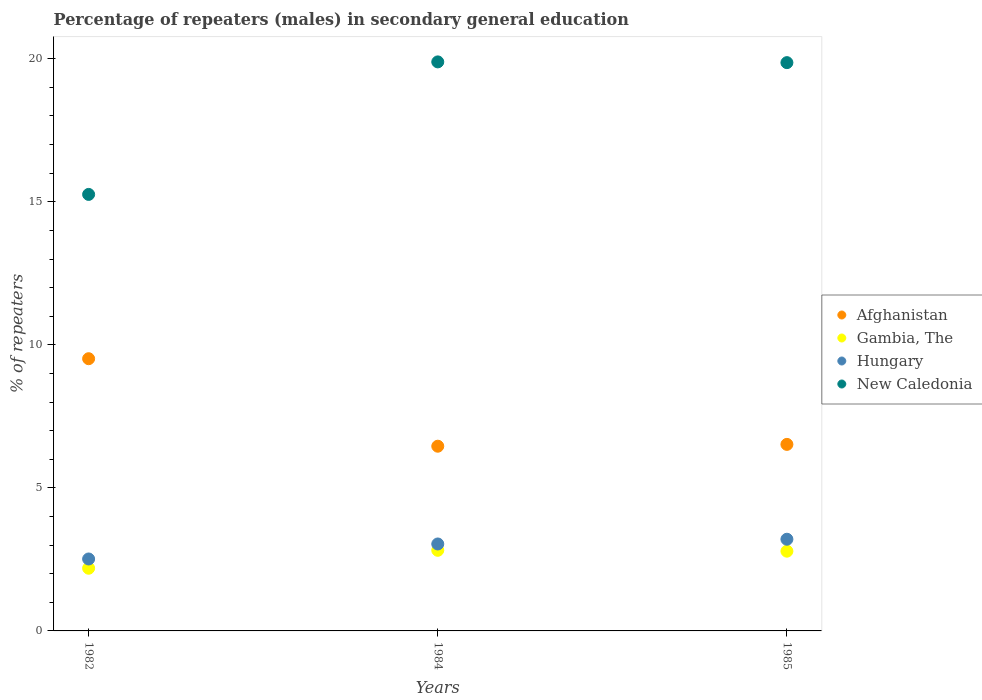Is the number of dotlines equal to the number of legend labels?
Ensure brevity in your answer.  Yes. What is the percentage of male repeaters in New Caledonia in 1985?
Give a very brief answer. 19.86. Across all years, what is the maximum percentage of male repeaters in Gambia, The?
Give a very brief answer. 2.82. Across all years, what is the minimum percentage of male repeaters in New Caledonia?
Offer a terse response. 15.26. In which year was the percentage of male repeaters in New Caledonia minimum?
Offer a terse response. 1982. What is the total percentage of male repeaters in Hungary in the graph?
Keep it short and to the point. 8.76. What is the difference between the percentage of male repeaters in Afghanistan in 1982 and that in 1984?
Keep it short and to the point. 3.06. What is the difference between the percentage of male repeaters in Afghanistan in 1985 and the percentage of male repeaters in New Caledonia in 1984?
Make the answer very short. -13.37. What is the average percentage of male repeaters in Gambia, The per year?
Your response must be concise. 2.6. In the year 1982, what is the difference between the percentage of male repeaters in Gambia, The and percentage of male repeaters in Hungary?
Offer a terse response. -0.32. In how many years, is the percentage of male repeaters in Afghanistan greater than 9 %?
Offer a terse response. 1. What is the ratio of the percentage of male repeaters in Hungary in 1982 to that in 1984?
Keep it short and to the point. 0.83. Is the percentage of male repeaters in Gambia, The in 1984 less than that in 1985?
Your answer should be very brief. No. What is the difference between the highest and the second highest percentage of male repeaters in Hungary?
Keep it short and to the point. 0.17. What is the difference between the highest and the lowest percentage of male repeaters in Gambia, The?
Your answer should be compact. 0.63. In how many years, is the percentage of male repeaters in Afghanistan greater than the average percentage of male repeaters in Afghanistan taken over all years?
Give a very brief answer. 1. Is the percentage of male repeaters in New Caledonia strictly greater than the percentage of male repeaters in Hungary over the years?
Give a very brief answer. Yes. Is the percentage of male repeaters in Hungary strictly less than the percentage of male repeaters in Afghanistan over the years?
Your answer should be very brief. Yes. What is the difference between two consecutive major ticks on the Y-axis?
Your answer should be compact. 5. Are the values on the major ticks of Y-axis written in scientific E-notation?
Keep it short and to the point. No. Does the graph contain any zero values?
Your response must be concise. No. Does the graph contain grids?
Ensure brevity in your answer.  No. Where does the legend appear in the graph?
Offer a very short reply. Center right. How many legend labels are there?
Provide a succinct answer. 4. What is the title of the graph?
Offer a terse response. Percentage of repeaters (males) in secondary general education. Does "Burkina Faso" appear as one of the legend labels in the graph?
Provide a short and direct response. No. What is the label or title of the Y-axis?
Give a very brief answer. % of repeaters. What is the % of repeaters in Afghanistan in 1982?
Provide a short and direct response. 9.52. What is the % of repeaters of Gambia, The in 1982?
Provide a short and direct response. 2.19. What is the % of repeaters in Hungary in 1982?
Provide a succinct answer. 2.51. What is the % of repeaters of New Caledonia in 1982?
Your answer should be compact. 15.26. What is the % of repeaters of Afghanistan in 1984?
Provide a short and direct response. 6.46. What is the % of repeaters in Gambia, The in 1984?
Provide a short and direct response. 2.82. What is the % of repeaters of Hungary in 1984?
Provide a short and direct response. 3.04. What is the % of repeaters in New Caledonia in 1984?
Offer a terse response. 19.89. What is the % of repeaters in Afghanistan in 1985?
Ensure brevity in your answer.  6.52. What is the % of repeaters of Gambia, The in 1985?
Your response must be concise. 2.79. What is the % of repeaters in Hungary in 1985?
Give a very brief answer. 3.2. What is the % of repeaters in New Caledonia in 1985?
Provide a short and direct response. 19.86. Across all years, what is the maximum % of repeaters of Afghanistan?
Offer a terse response. 9.52. Across all years, what is the maximum % of repeaters in Gambia, The?
Give a very brief answer. 2.82. Across all years, what is the maximum % of repeaters in Hungary?
Ensure brevity in your answer.  3.2. Across all years, what is the maximum % of repeaters of New Caledonia?
Ensure brevity in your answer.  19.89. Across all years, what is the minimum % of repeaters in Afghanistan?
Keep it short and to the point. 6.46. Across all years, what is the minimum % of repeaters in Gambia, The?
Your response must be concise. 2.19. Across all years, what is the minimum % of repeaters of Hungary?
Provide a short and direct response. 2.51. Across all years, what is the minimum % of repeaters of New Caledonia?
Your answer should be very brief. 15.26. What is the total % of repeaters in Afghanistan in the graph?
Your answer should be very brief. 22.49. What is the total % of repeaters of Gambia, The in the graph?
Your response must be concise. 7.8. What is the total % of repeaters of Hungary in the graph?
Give a very brief answer. 8.76. What is the total % of repeaters in New Caledonia in the graph?
Your answer should be compact. 55.01. What is the difference between the % of repeaters of Afghanistan in 1982 and that in 1984?
Give a very brief answer. 3.06. What is the difference between the % of repeaters in Gambia, The in 1982 and that in 1984?
Keep it short and to the point. -0.63. What is the difference between the % of repeaters in Hungary in 1982 and that in 1984?
Your response must be concise. -0.52. What is the difference between the % of repeaters of New Caledonia in 1982 and that in 1984?
Offer a very short reply. -4.63. What is the difference between the % of repeaters in Afghanistan in 1982 and that in 1985?
Offer a terse response. 3. What is the difference between the % of repeaters of Gambia, The in 1982 and that in 1985?
Your answer should be compact. -0.6. What is the difference between the % of repeaters in Hungary in 1982 and that in 1985?
Offer a terse response. -0.69. What is the difference between the % of repeaters in New Caledonia in 1982 and that in 1985?
Your response must be concise. -4.61. What is the difference between the % of repeaters in Afghanistan in 1984 and that in 1985?
Your response must be concise. -0.06. What is the difference between the % of repeaters in Gambia, The in 1984 and that in 1985?
Make the answer very short. 0.03. What is the difference between the % of repeaters in Hungary in 1984 and that in 1985?
Make the answer very short. -0.17. What is the difference between the % of repeaters of New Caledonia in 1984 and that in 1985?
Keep it short and to the point. 0.03. What is the difference between the % of repeaters in Afghanistan in 1982 and the % of repeaters in Gambia, The in 1984?
Your answer should be compact. 6.7. What is the difference between the % of repeaters of Afghanistan in 1982 and the % of repeaters of Hungary in 1984?
Make the answer very short. 6.48. What is the difference between the % of repeaters in Afghanistan in 1982 and the % of repeaters in New Caledonia in 1984?
Offer a very short reply. -10.38. What is the difference between the % of repeaters of Gambia, The in 1982 and the % of repeaters of Hungary in 1984?
Give a very brief answer. -0.85. What is the difference between the % of repeaters of Gambia, The in 1982 and the % of repeaters of New Caledonia in 1984?
Offer a terse response. -17.7. What is the difference between the % of repeaters in Hungary in 1982 and the % of repeaters in New Caledonia in 1984?
Offer a terse response. -17.38. What is the difference between the % of repeaters of Afghanistan in 1982 and the % of repeaters of Gambia, The in 1985?
Your answer should be very brief. 6.73. What is the difference between the % of repeaters of Afghanistan in 1982 and the % of repeaters of Hungary in 1985?
Make the answer very short. 6.31. What is the difference between the % of repeaters of Afghanistan in 1982 and the % of repeaters of New Caledonia in 1985?
Make the answer very short. -10.35. What is the difference between the % of repeaters of Gambia, The in 1982 and the % of repeaters of Hungary in 1985?
Your answer should be very brief. -1.01. What is the difference between the % of repeaters of Gambia, The in 1982 and the % of repeaters of New Caledonia in 1985?
Make the answer very short. -17.67. What is the difference between the % of repeaters in Hungary in 1982 and the % of repeaters in New Caledonia in 1985?
Ensure brevity in your answer.  -17.35. What is the difference between the % of repeaters of Afghanistan in 1984 and the % of repeaters of Gambia, The in 1985?
Provide a short and direct response. 3.67. What is the difference between the % of repeaters in Afghanistan in 1984 and the % of repeaters in Hungary in 1985?
Your response must be concise. 3.25. What is the difference between the % of repeaters of Afghanistan in 1984 and the % of repeaters of New Caledonia in 1985?
Provide a short and direct response. -13.41. What is the difference between the % of repeaters in Gambia, The in 1984 and the % of repeaters in Hungary in 1985?
Your answer should be very brief. -0.39. What is the difference between the % of repeaters of Gambia, The in 1984 and the % of repeaters of New Caledonia in 1985?
Provide a succinct answer. -17.05. What is the difference between the % of repeaters in Hungary in 1984 and the % of repeaters in New Caledonia in 1985?
Your answer should be very brief. -16.83. What is the average % of repeaters of Afghanistan per year?
Your response must be concise. 7.5. What is the average % of repeaters in Gambia, The per year?
Your answer should be very brief. 2.6. What is the average % of repeaters in Hungary per year?
Keep it short and to the point. 2.92. What is the average % of repeaters of New Caledonia per year?
Offer a very short reply. 18.34. In the year 1982, what is the difference between the % of repeaters in Afghanistan and % of repeaters in Gambia, The?
Keep it short and to the point. 7.32. In the year 1982, what is the difference between the % of repeaters in Afghanistan and % of repeaters in Hungary?
Ensure brevity in your answer.  7. In the year 1982, what is the difference between the % of repeaters of Afghanistan and % of repeaters of New Caledonia?
Provide a short and direct response. -5.74. In the year 1982, what is the difference between the % of repeaters of Gambia, The and % of repeaters of Hungary?
Give a very brief answer. -0.32. In the year 1982, what is the difference between the % of repeaters of Gambia, The and % of repeaters of New Caledonia?
Provide a succinct answer. -13.07. In the year 1982, what is the difference between the % of repeaters of Hungary and % of repeaters of New Caledonia?
Your answer should be compact. -12.74. In the year 1984, what is the difference between the % of repeaters of Afghanistan and % of repeaters of Gambia, The?
Make the answer very short. 3.64. In the year 1984, what is the difference between the % of repeaters of Afghanistan and % of repeaters of Hungary?
Keep it short and to the point. 3.42. In the year 1984, what is the difference between the % of repeaters of Afghanistan and % of repeaters of New Caledonia?
Your answer should be very brief. -13.43. In the year 1984, what is the difference between the % of repeaters of Gambia, The and % of repeaters of Hungary?
Give a very brief answer. -0.22. In the year 1984, what is the difference between the % of repeaters in Gambia, The and % of repeaters in New Caledonia?
Your answer should be compact. -17.07. In the year 1984, what is the difference between the % of repeaters of Hungary and % of repeaters of New Caledonia?
Make the answer very short. -16.85. In the year 1985, what is the difference between the % of repeaters in Afghanistan and % of repeaters in Gambia, The?
Provide a succinct answer. 3.73. In the year 1985, what is the difference between the % of repeaters of Afghanistan and % of repeaters of Hungary?
Ensure brevity in your answer.  3.32. In the year 1985, what is the difference between the % of repeaters in Afghanistan and % of repeaters in New Caledonia?
Your response must be concise. -13.34. In the year 1985, what is the difference between the % of repeaters in Gambia, The and % of repeaters in Hungary?
Your response must be concise. -0.42. In the year 1985, what is the difference between the % of repeaters of Gambia, The and % of repeaters of New Caledonia?
Your answer should be very brief. -17.08. In the year 1985, what is the difference between the % of repeaters of Hungary and % of repeaters of New Caledonia?
Offer a very short reply. -16.66. What is the ratio of the % of repeaters in Afghanistan in 1982 to that in 1984?
Ensure brevity in your answer.  1.47. What is the ratio of the % of repeaters of Gambia, The in 1982 to that in 1984?
Your response must be concise. 0.78. What is the ratio of the % of repeaters of Hungary in 1982 to that in 1984?
Ensure brevity in your answer.  0.83. What is the ratio of the % of repeaters in New Caledonia in 1982 to that in 1984?
Provide a succinct answer. 0.77. What is the ratio of the % of repeaters of Afghanistan in 1982 to that in 1985?
Offer a terse response. 1.46. What is the ratio of the % of repeaters in Gambia, The in 1982 to that in 1985?
Your answer should be very brief. 0.79. What is the ratio of the % of repeaters in Hungary in 1982 to that in 1985?
Your response must be concise. 0.78. What is the ratio of the % of repeaters in New Caledonia in 1982 to that in 1985?
Keep it short and to the point. 0.77. What is the ratio of the % of repeaters of Afghanistan in 1984 to that in 1985?
Provide a short and direct response. 0.99. What is the ratio of the % of repeaters in Gambia, The in 1984 to that in 1985?
Offer a terse response. 1.01. What is the ratio of the % of repeaters of Hungary in 1984 to that in 1985?
Make the answer very short. 0.95. What is the ratio of the % of repeaters of New Caledonia in 1984 to that in 1985?
Keep it short and to the point. 1. What is the difference between the highest and the second highest % of repeaters of Afghanistan?
Your response must be concise. 3. What is the difference between the highest and the second highest % of repeaters of Gambia, The?
Offer a very short reply. 0.03. What is the difference between the highest and the second highest % of repeaters in Hungary?
Your answer should be compact. 0.17. What is the difference between the highest and the second highest % of repeaters of New Caledonia?
Keep it short and to the point. 0.03. What is the difference between the highest and the lowest % of repeaters of Afghanistan?
Give a very brief answer. 3.06. What is the difference between the highest and the lowest % of repeaters in Gambia, The?
Offer a terse response. 0.63. What is the difference between the highest and the lowest % of repeaters of Hungary?
Your answer should be compact. 0.69. What is the difference between the highest and the lowest % of repeaters of New Caledonia?
Make the answer very short. 4.63. 